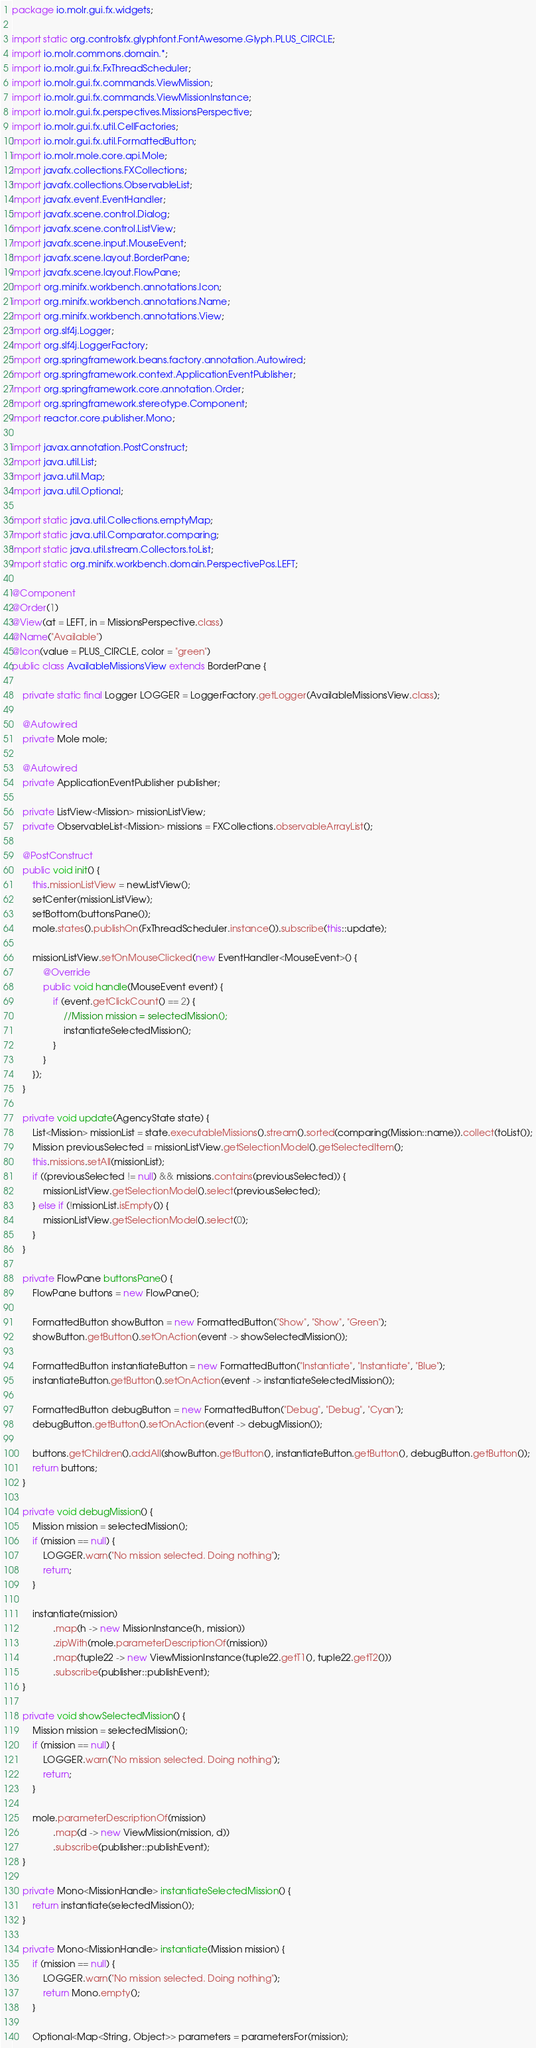Convert code to text. <code><loc_0><loc_0><loc_500><loc_500><_Java_>package io.molr.gui.fx.widgets;

import static org.controlsfx.glyphfont.FontAwesome.Glyph.PLUS_CIRCLE;
import io.molr.commons.domain.*;
import io.molr.gui.fx.FxThreadScheduler;
import io.molr.gui.fx.commands.ViewMission;
import io.molr.gui.fx.commands.ViewMissionInstance;
import io.molr.gui.fx.perspectives.MissionsPerspective;
import io.molr.gui.fx.util.CellFactories;
import io.molr.gui.fx.util.FormattedButton;
import io.molr.mole.core.api.Mole;
import javafx.collections.FXCollections;
import javafx.collections.ObservableList;
import javafx.event.EventHandler;
import javafx.scene.control.Dialog;
import javafx.scene.control.ListView;
import javafx.scene.input.MouseEvent;
import javafx.scene.layout.BorderPane;
import javafx.scene.layout.FlowPane;
import org.minifx.workbench.annotations.Icon;
import org.minifx.workbench.annotations.Name;
import org.minifx.workbench.annotations.View;
import org.slf4j.Logger;
import org.slf4j.LoggerFactory;
import org.springframework.beans.factory.annotation.Autowired;
import org.springframework.context.ApplicationEventPublisher;
import org.springframework.core.annotation.Order;
import org.springframework.stereotype.Component;
import reactor.core.publisher.Mono;

import javax.annotation.PostConstruct;
import java.util.List;
import java.util.Map;
import java.util.Optional;

import static java.util.Collections.emptyMap;
import static java.util.Comparator.comparing;
import static java.util.stream.Collectors.toList;
import static org.minifx.workbench.domain.PerspectivePos.LEFT;

@Component
@Order(1)
@View(at = LEFT, in = MissionsPerspective.class)
@Name("Available")
@Icon(value = PLUS_CIRCLE, color = "green")
public class AvailableMissionsView extends BorderPane {

    private static final Logger LOGGER = LoggerFactory.getLogger(AvailableMissionsView.class);

    @Autowired
    private Mole mole;

    @Autowired
    private ApplicationEventPublisher publisher;

    private ListView<Mission> missionListView;
    private ObservableList<Mission> missions = FXCollections.observableArrayList();

    @PostConstruct
    public void init() {
        this.missionListView = newListView();
        setCenter(missionListView);
        setBottom(buttonsPane());
        mole.states().publishOn(FxThreadScheduler.instance()).subscribe(this::update);

        missionListView.setOnMouseClicked(new EventHandler<MouseEvent>() {
            @Override
            public void handle(MouseEvent event) {
                if (event.getClickCount() == 2) {
                    //Mission mission = selectedMission();
                    instantiateSelectedMission();
                }
            }
        });
    }

    private void update(AgencyState state) {
        List<Mission> missionList = state.executableMissions().stream().sorted(comparing(Mission::name)).collect(toList());
        Mission previousSelected = missionListView.getSelectionModel().getSelectedItem();
        this.missions.setAll(missionList);
        if ((previousSelected != null) && missions.contains(previousSelected)) {
            missionListView.getSelectionModel().select(previousSelected);
        } else if (!missionList.isEmpty()) {
            missionListView.getSelectionModel().select(0);
        }
    }

    private FlowPane buttonsPane() {
        FlowPane buttons = new FlowPane();

        FormattedButton showButton = new FormattedButton("Show", "Show", "Green");
        showButton.getButton().setOnAction(event -> showSelectedMission());

        FormattedButton instantiateButton = new FormattedButton("Instantiate", "Instantiate", "Blue");
        instantiateButton.getButton().setOnAction(event -> instantiateSelectedMission());

        FormattedButton debugButton = new FormattedButton("Debug", "Debug", "Cyan");
        debugButton.getButton().setOnAction(event -> debugMission());

        buttons.getChildren().addAll(showButton.getButton(), instantiateButton.getButton(), debugButton.getButton());
        return buttons;
    }

    private void debugMission() {
        Mission mission = selectedMission();
        if (mission == null) {
            LOGGER.warn("No mission selected. Doing nothing");
            return;
        }

        instantiate(mission)
                .map(h -> new MissionInstance(h, mission))
                .zipWith(mole.parameterDescriptionOf(mission))
                .map(tuple22 -> new ViewMissionInstance(tuple22.getT1(), tuple22.getT2()))
                .subscribe(publisher::publishEvent);
    }

    private void showSelectedMission() {
        Mission mission = selectedMission();
        if (mission == null) {
            LOGGER.warn("No mission selected. Doing nothing");
            return;
        }

        mole.parameterDescriptionOf(mission)
                .map(d -> new ViewMission(mission, d))
                .subscribe(publisher::publishEvent);
    }

    private Mono<MissionHandle> instantiateSelectedMission() {
        return instantiate(selectedMission());
    }

    private Mono<MissionHandle> instantiate(Mission mission) {
        if (mission == null) {
            LOGGER.warn("No mission selected. Doing nothing");
            return Mono.empty();
        }

        Optional<Map<String, Object>> parameters = parametersFor(mission);</code> 